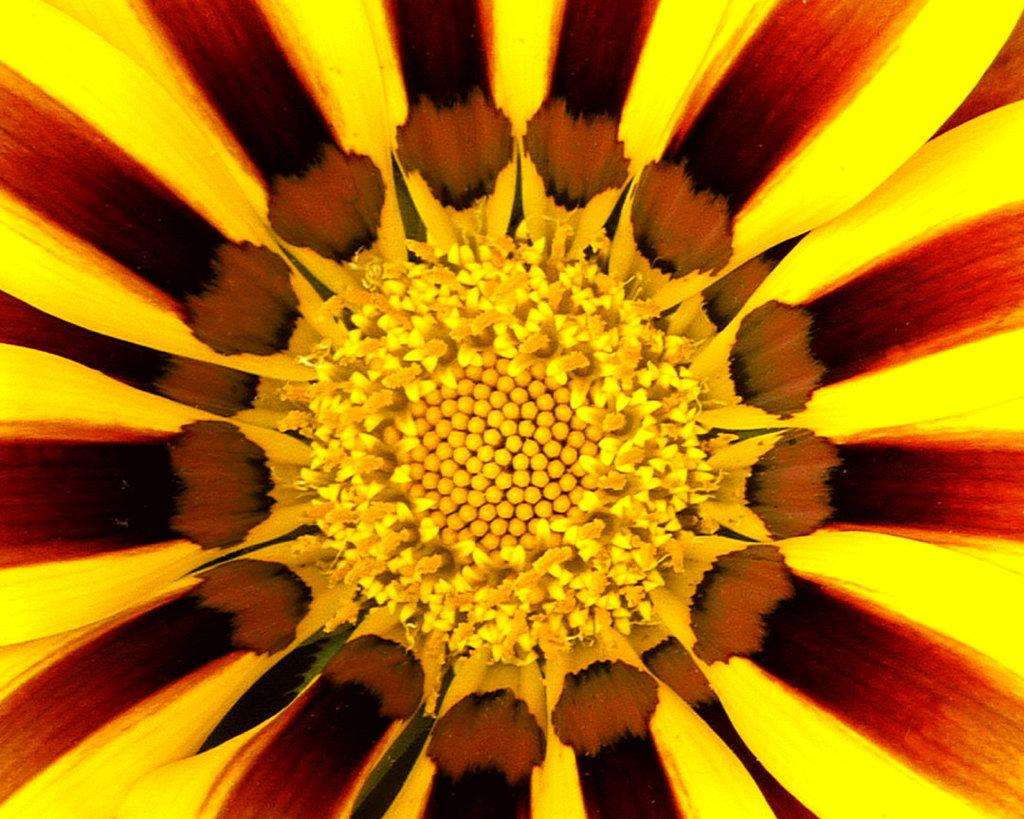What is the main subject of the image? The main subject of the image is a flower. Can you describe the flower in the image? The image is a zoomed in picture of a flower, so we can see the details of the petals, stamen, and other parts of the flower. What type of jelly is being used to decorate the flower in the image? There is no jelly present in the image; it is a picture of a flower. Can you see any skirts or clothing items in the image? No, the image only features a flower, and there are no clothing items or skirts visible. 